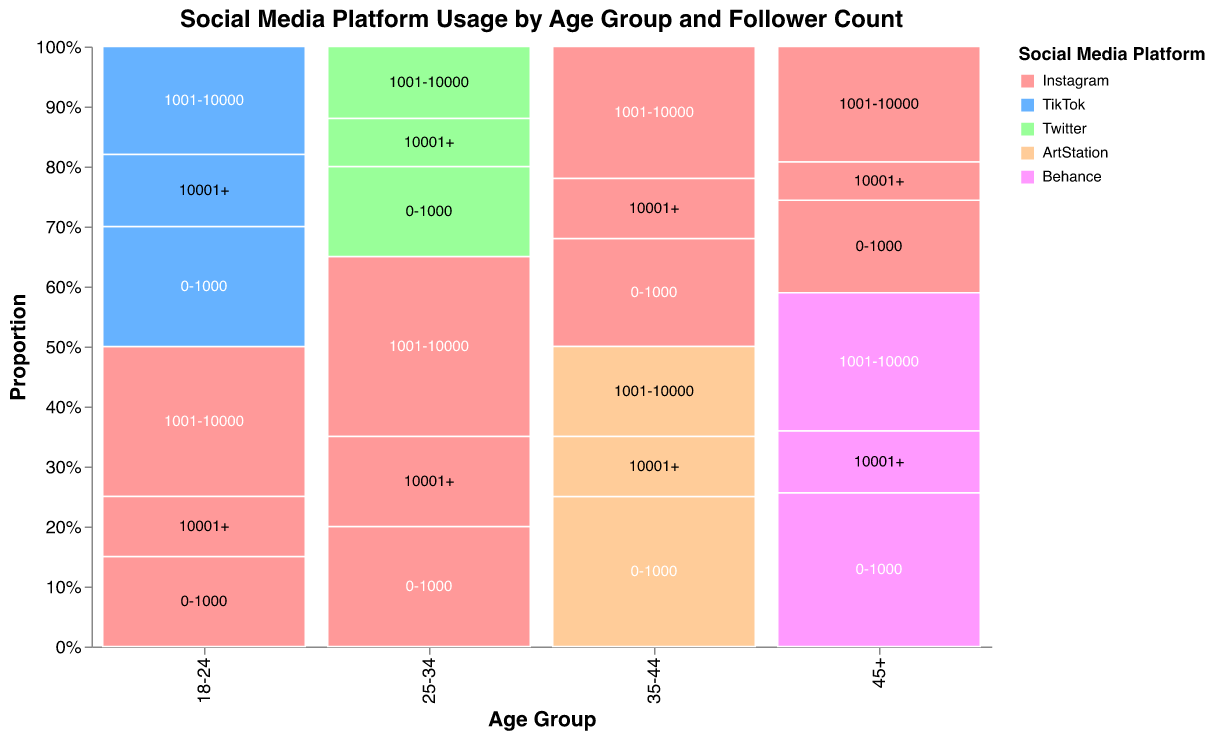What is the most popular social media platform for the 18-24 age group? Looking at the 18-24 age group, the largest portions of the Mosaic Plot show Instagram, reflecting the highest percentages, summing to a total of 15 + 25 + 10 = 50%.
Answer: Instagram Which social media platform is used least by the 25-34 age group? In the 25-34 age group, Twitter has the smallest segments, totaling 15 + 12 + 8 = 35%.
Answer: Twitter In the 35-44 age group, which follower count range for ArtStation has the highest percentage usage? For ArtStation in the 35-44 age group, the highest percentage is in the 0-1000 follower count range, which stands at 25%.
Answer: 0-1000 How does Instagram usage for the 45+ age group compare to Behance usage in terms of follower count? For 45+ age group, Instagram: 12% (0-1000) + 15% (1001-10000) + 5% (10001+) = 32%. Behance: 20% (0-1000) + 18% (1001-10000) + 8% (10001+) = 46%. Since 32% < 46%, Behance is more used than Instagram in this age group.
Answer: Behance is used more What is the overall trend in Instagram usage across different age groups with the highest follower count (10001+)? Checking each age group's Instagram usage in the 10001+ follower count: 18-24 (10%), 25-34 (15%), 35-44 (10%), 45+ (5%). The trend shows a higher percentage in the middle age groups, peaking at 25-34, and lower in the youngest and oldest groups.
Answer: Peaks at 25-34 and decreases in the youngest and oldest groups What age group shows the highest usage of TikTok for self-promotion? Looking at the segments representing TikTok usage across age groups, the 18-24 age group shows the highest usage with a total of 20% (0-1000) + 18% (1001-10000) + 12% (10001+) = 50%.
Answer: 18-24 Which age group has the most balanced usage across all social media platforms? Checking each age group’s Mosaic Plot for balance across platforms, 35-44 shows more distributed percentages across Instagram and ArtStation: Instagram (50%) and ArtStation (50%). In contrast, the other age groups show more pronounced differences.
Answer: 35-44 How does the distribution between different follower counts within the Instagram platform look for the 25-34 age group? For 25-34 on Instagram, the percentages are 20% (0-1000), 30% (1001-10000), and 15% (10001+). This distribution shows a heavier skew towards the 1001-10000 range.
Answer: Skewed towards 1001-10000 What is the least common follower count range across all platforms and age groups? Looking through the entire data, the lowest percentages come from the Instagram 10001+ (45+), Twitter 10001+ (25-34), Behance 10001+ (45+), and ArtStation 10001+ (35-44) segments, each standing at 5%, 8%, 8% and 10%, respectively.
Answer: Instagram 10001+ (45+) In the 18-24 age group, how do the percentages of TikTok compare between the 0-1000 and 10001+ follower count ranges? For the 18-24 age group, TikTok percentages are 20% (0-1000) and 12% (10001+), showing TikTok usage is significantly higher for the 0-1000 follower range compared to the 10001+ range.
Answer: Higher for 0-1000 